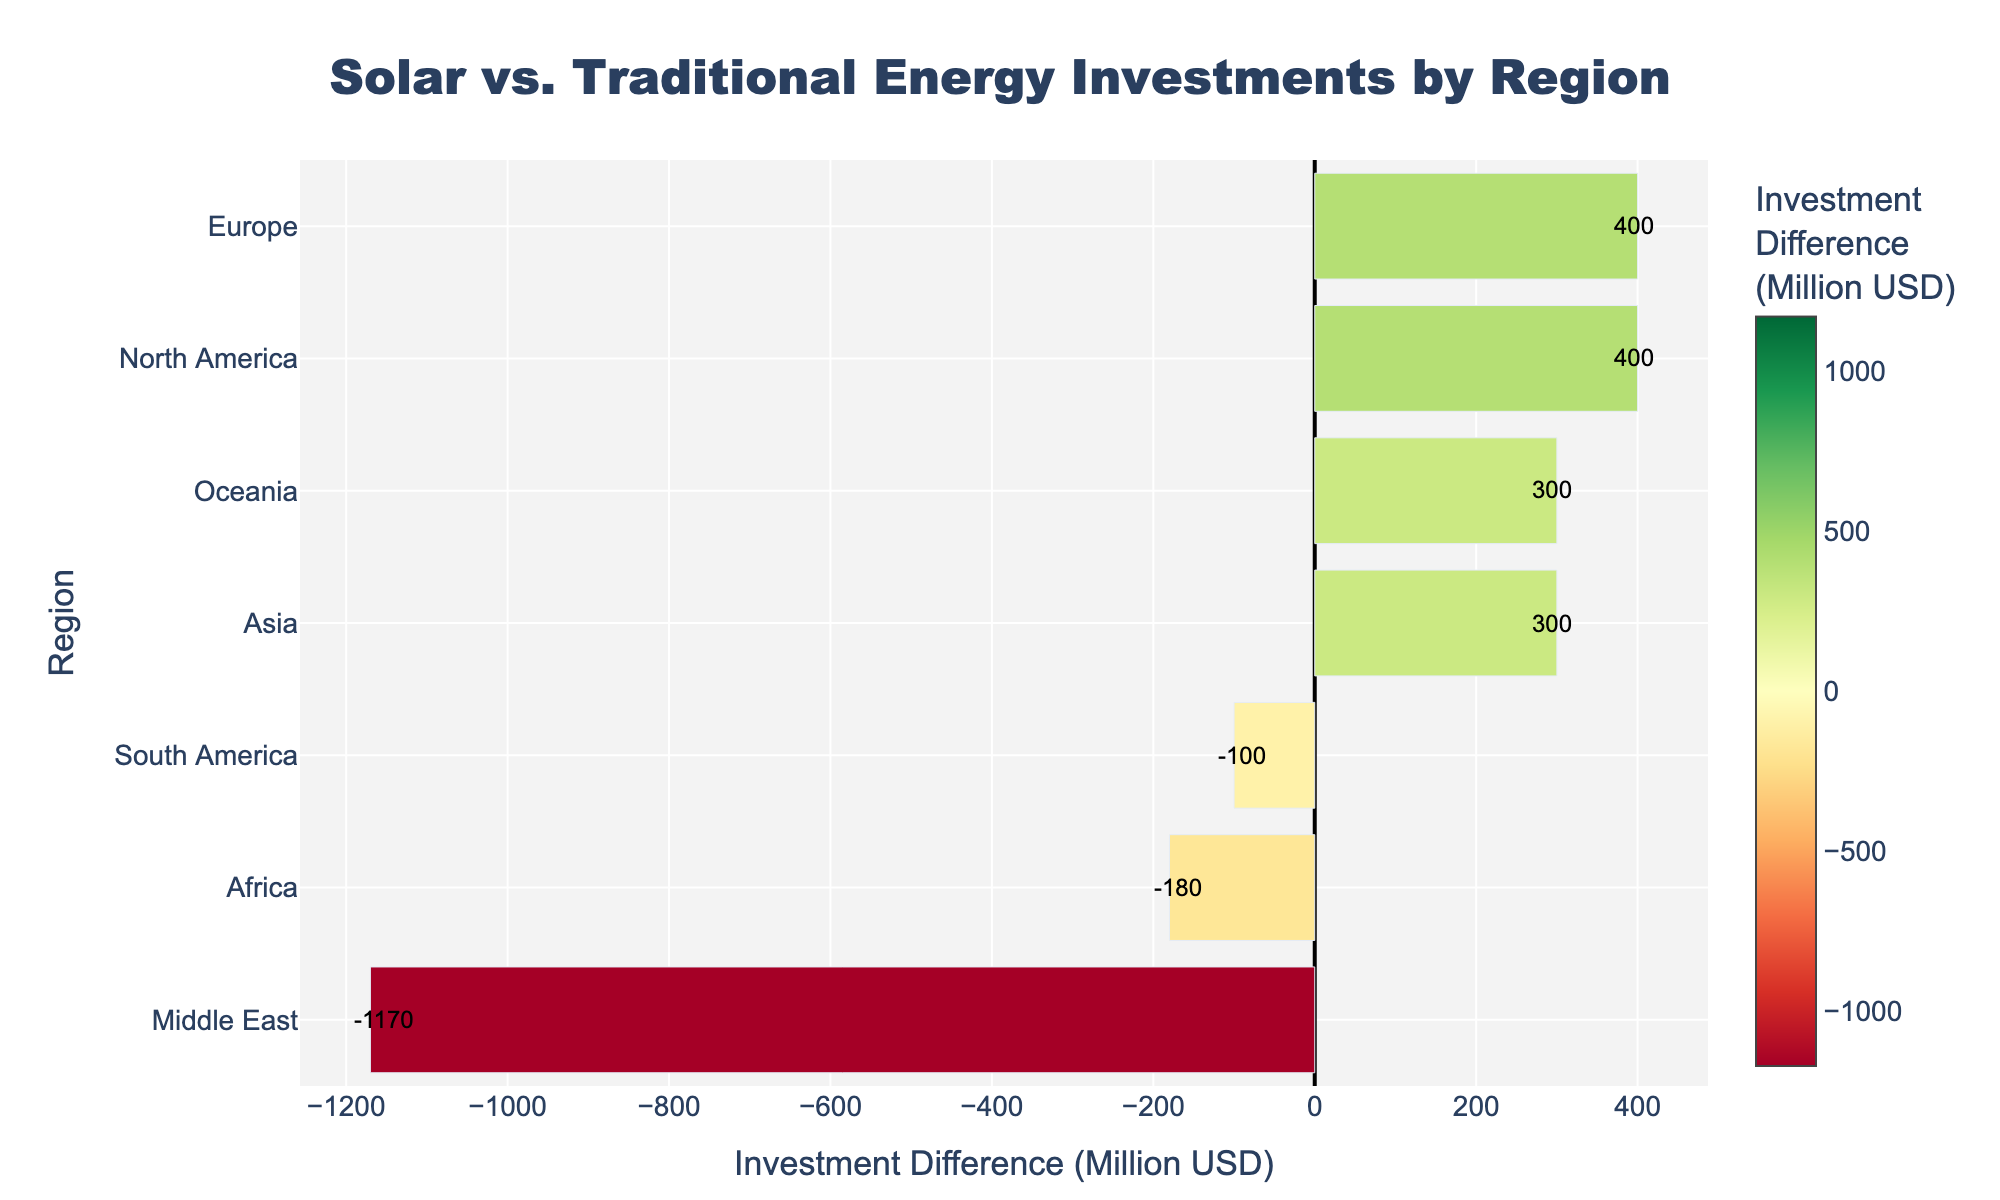Which region has the highest net investment in solar energy compared to traditional energy? Asia has the highest positive difference in net investment in solar energy compared to traditional energy, as indicated by the rightmost and largest positive value in the chart.
Answer: Asia Which region shows the most significant negative difference between solar and traditional energy investments? The Middle East shows the most significant negative difference between solar and traditional energy investments, as it has the largest negative value on the left side of the diverging bar chart.
Answer: Middle East What is the combined investment difference for North America and Europe? North America's investment difference is +400 (1200 - 800) and Europe's investment difference is +400 (1500 - 1100). Combining these, we get 400 + 400 = 800.
Answer: 800 Compare the investment differences in South America and Oceania. Which one is greater, and by how much? South America's investment difference is -100 (850 - 950), and Oceania's is +300 (600 - 300). The difference between these two is 300 - (-100) = 400. Oceania's investment difference is greater by 400.
Answer: Oceania by 400 Which regions have a positive net investment difference in solar energy as compared to traditional energy investments? The regions with positive net investment differences (positive bars on the right) are North America, Europe, Asia, and Oceania.
Answer: North America, Europe, Asia, Oceania What is the average net investment difference for all regions shown in the chart? The net investment differences are: 400 (North America), -100 (South America), 400 (Europe), -1170 (Middle East), -180 (Africa), 300 (Oceania), and 300 (Asia). Summing these, we get 400 + (-100) + 400 + (-1170) + (-180) + 300 + 300 = -50. The average is -50 / 7 ≈ -7.14.
Answer: -7.14 How does the net investment difference in Africa compare to South America's? Africa's net investment difference is -180 (420 - 600), and South America's is -100 (850 - 950). Africa's net investment difference is 80 million USD less than South America's.
Answer: Africa by 80 less What color represents the largest positive investment difference, and which region does it correspond to? The largest positive investment difference is represented by the most intense green color, which corresponds to the Asia region.
Answer: Green, Asia Which three regions have the smallest absolute investment differences, and what are their values? The three regions are South America (-100), Africa (-180), and Oceania (300), having the smallest absolute investment differences.
Answer: South America (-100), Africa (-180), Oceania (300) By what factor is the net investment difference in the Middle East greater than that in Oceania? The net investment difference in the Middle East is -1170, and the difference in Oceania is 300. The factor is 1170 / 300 = 3.9. The Middle East's net investment difference is greater by a factor of about 3.9.
Answer: 3.9 